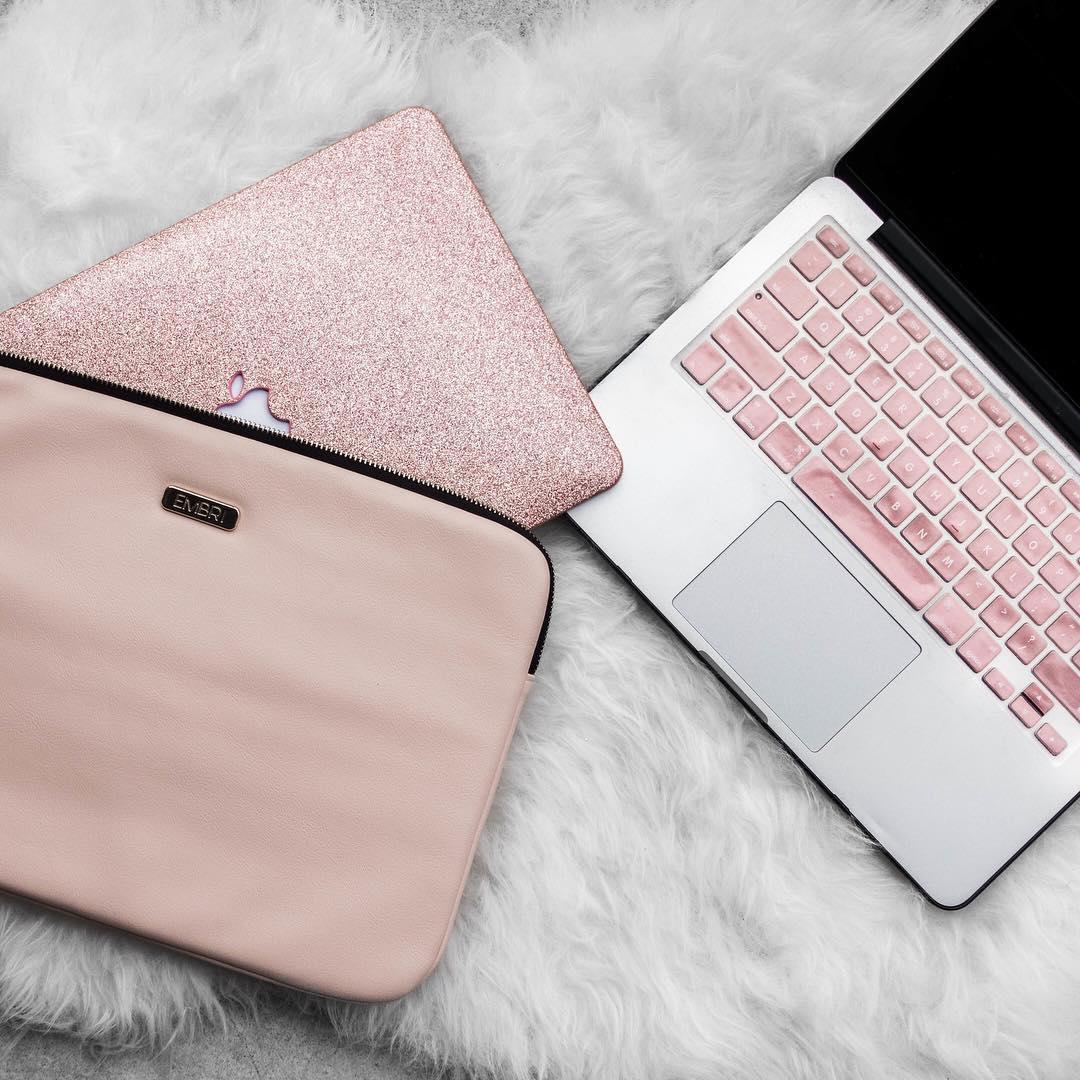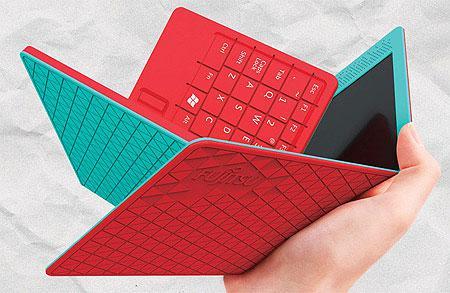The first image is the image on the left, the second image is the image on the right. Assess this claim about the two images: "A person's hand is near a digital device.". Correct or not? Answer yes or no. Yes. The first image is the image on the left, the second image is the image on the right. For the images displayed, is the sentence "An image shows an open red device and a device with a patterned cover posed back-to-back in front of rows of closed devices." factually correct? Answer yes or no. No. 